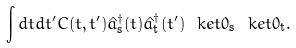<formula> <loc_0><loc_0><loc_500><loc_500>\int d t d t ^ { \prime } C ( t , t ^ { \prime } ) \hat { a } _ { \text {s} } ^ { \dagger } ( t ) \hat { a } _ { \text {t} } ^ { \dagger } ( t ^ { \prime } ) \ k e t { 0 } _ { \text {s} } \ k e t { 0 } _ { \text {t} } .</formula> 